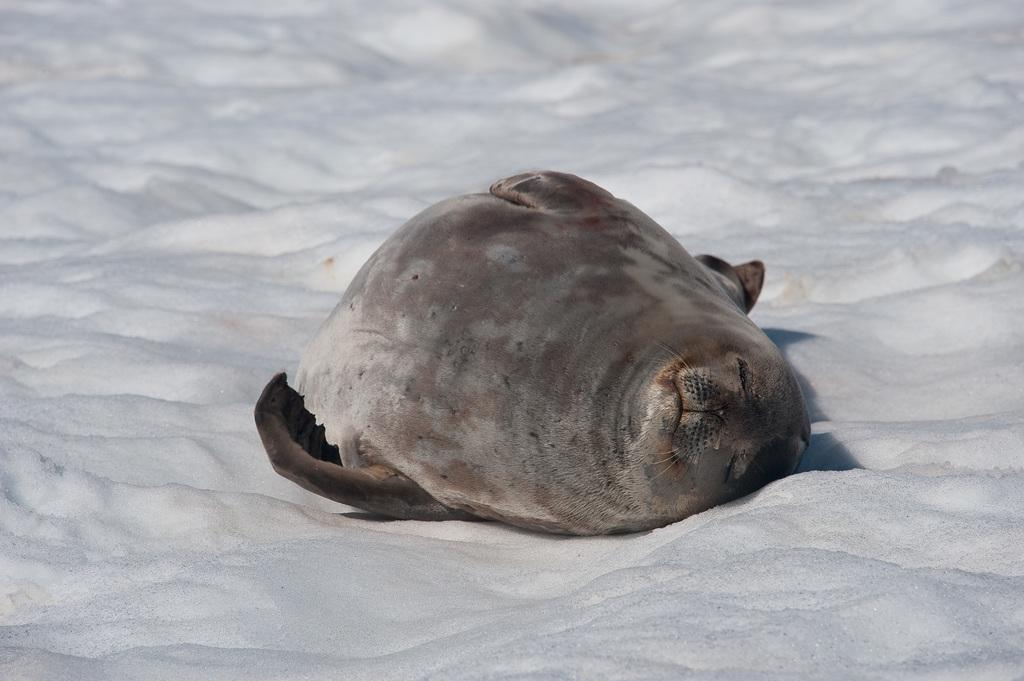What type of animal is in the image? There is an animal in the image, but the specific type cannot be determined from the provided facts. Where is the animal located in the image? The animal is on the snow in the image. What is the name of the kitty that is playing with a jar in the image? There is no kitty or jar present in the image; it features an animal on the snow. 